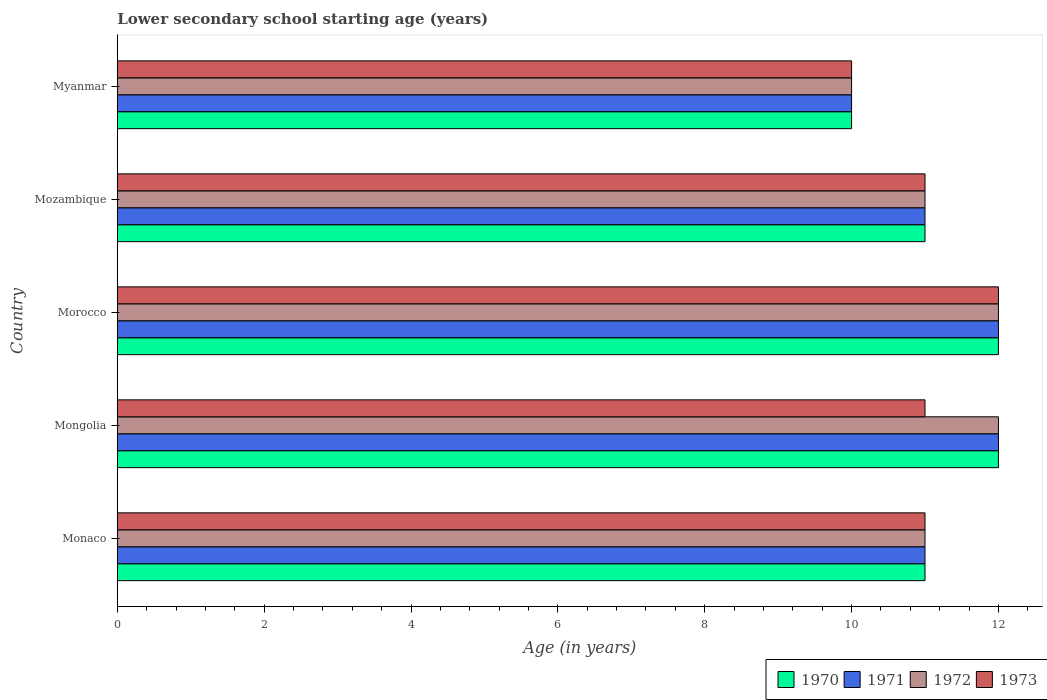Are the number of bars per tick equal to the number of legend labels?
Your answer should be very brief. Yes. Are the number of bars on each tick of the Y-axis equal?
Provide a succinct answer. Yes. How many bars are there on the 4th tick from the bottom?
Ensure brevity in your answer.  4. What is the label of the 4th group of bars from the top?
Provide a short and direct response. Mongolia. In how many cases, is the number of bars for a given country not equal to the number of legend labels?
Your response must be concise. 0. In which country was the lower secondary school starting age of children in 1972 maximum?
Give a very brief answer. Mongolia. In which country was the lower secondary school starting age of children in 1973 minimum?
Offer a terse response. Myanmar. What is the difference between the lower secondary school starting age of children in 1970 in Monaco and that in Mozambique?
Provide a succinct answer. 0. What is the difference between the lower secondary school starting age of children in 1970 in Mozambique and the lower secondary school starting age of children in 1973 in Mongolia?
Ensure brevity in your answer.  0. What is the average lower secondary school starting age of children in 1970 per country?
Make the answer very short. 11.2. In how many countries, is the lower secondary school starting age of children in 1972 greater than 9.6 years?
Provide a short and direct response. 5. What is the ratio of the lower secondary school starting age of children in 1971 in Monaco to that in Mozambique?
Offer a very short reply. 1. Is the lower secondary school starting age of children in 1973 in Mongolia less than that in Morocco?
Your answer should be very brief. Yes. Is the difference between the lower secondary school starting age of children in 1971 in Mongolia and Mozambique greater than the difference between the lower secondary school starting age of children in 1973 in Mongolia and Mozambique?
Provide a succinct answer. Yes. Is the sum of the lower secondary school starting age of children in 1971 in Monaco and Morocco greater than the maximum lower secondary school starting age of children in 1972 across all countries?
Offer a very short reply. Yes. Is it the case that in every country, the sum of the lower secondary school starting age of children in 1970 and lower secondary school starting age of children in 1971 is greater than the sum of lower secondary school starting age of children in 1973 and lower secondary school starting age of children in 1972?
Make the answer very short. No. What does the 4th bar from the top in Monaco represents?
Make the answer very short. 1970. What does the 4th bar from the bottom in Morocco represents?
Make the answer very short. 1973. How many bars are there?
Your answer should be very brief. 20. Are all the bars in the graph horizontal?
Provide a succinct answer. Yes. How many countries are there in the graph?
Your response must be concise. 5. Are the values on the major ticks of X-axis written in scientific E-notation?
Make the answer very short. No. Does the graph contain any zero values?
Offer a very short reply. No. How many legend labels are there?
Ensure brevity in your answer.  4. How are the legend labels stacked?
Offer a very short reply. Horizontal. What is the title of the graph?
Provide a succinct answer. Lower secondary school starting age (years). Does "1994" appear as one of the legend labels in the graph?
Ensure brevity in your answer.  No. What is the label or title of the X-axis?
Give a very brief answer. Age (in years). What is the Age (in years) in 1971 in Monaco?
Ensure brevity in your answer.  11. What is the Age (in years) in 1970 in Mongolia?
Your answer should be very brief. 12. What is the Age (in years) in 1973 in Mongolia?
Make the answer very short. 11. What is the Age (in years) in 1971 in Morocco?
Give a very brief answer. 12. What is the Age (in years) of 1972 in Morocco?
Your response must be concise. 12. What is the Age (in years) in 1973 in Morocco?
Your answer should be compact. 12. What is the Age (in years) in 1971 in Mozambique?
Your answer should be compact. 11. What is the Age (in years) of 1972 in Mozambique?
Your response must be concise. 11. What is the Age (in years) of 1971 in Myanmar?
Your response must be concise. 10. What is the Age (in years) of 1972 in Myanmar?
Your response must be concise. 10. What is the Age (in years) in 1973 in Myanmar?
Your answer should be compact. 10. Across all countries, what is the maximum Age (in years) of 1971?
Your answer should be very brief. 12. Across all countries, what is the maximum Age (in years) in 1972?
Offer a very short reply. 12. Across all countries, what is the maximum Age (in years) of 1973?
Your response must be concise. 12. Across all countries, what is the minimum Age (in years) of 1970?
Make the answer very short. 10. Across all countries, what is the minimum Age (in years) of 1972?
Ensure brevity in your answer.  10. What is the total Age (in years) of 1973 in the graph?
Provide a short and direct response. 55. What is the difference between the Age (in years) of 1970 in Monaco and that in Mongolia?
Provide a succinct answer. -1. What is the difference between the Age (in years) of 1971 in Monaco and that in Mongolia?
Offer a very short reply. -1. What is the difference between the Age (in years) in 1973 in Monaco and that in Mongolia?
Provide a succinct answer. 0. What is the difference between the Age (in years) in 1972 in Monaco and that in Morocco?
Ensure brevity in your answer.  -1. What is the difference between the Age (in years) in 1970 in Monaco and that in Mozambique?
Your answer should be very brief. 0. What is the difference between the Age (in years) in 1971 in Monaco and that in Myanmar?
Offer a terse response. 1. What is the difference between the Age (in years) in 1972 in Monaco and that in Myanmar?
Keep it short and to the point. 1. What is the difference between the Age (in years) of 1970 in Mongolia and that in Morocco?
Your answer should be compact. 0. What is the difference between the Age (in years) in 1971 in Mongolia and that in Morocco?
Make the answer very short. 0. What is the difference between the Age (in years) of 1973 in Mongolia and that in Morocco?
Ensure brevity in your answer.  -1. What is the difference between the Age (in years) in 1973 in Mongolia and that in Mozambique?
Provide a succinct answer. 0. What is the difference between the Age (in years) in 1971 in Mongolia and that in Myanmar?
Make the answer very short. 2. What is the difference between the Age (in years) in 1972 in Mongolia and that in Myanmar?
Your response must be concise. 2. What is the difference between the Age (in years) in 1973 in Mongolia and that in Myanmar?
Your answer should be compact. 1. What is the difference between the Age (in years) in 1972 in Morocco and that in Mozambique?
Keep it short and to the point. 1. What is the difference between the Age (in years) in 1973 in Morocco and that in Mozambique?
Make the answer very short. 1. What is the difference between the Age (in years) in 1971 in Morocco and that in Myanmar?
Keep it short and to the point. 2. What is the difference between the Age (in years) in 1973 in Morocco and that in Myanmar?
Provide a succinct answer. 2. What is the difference between the Age (in years) of 1973 in Mozambique and that in Myanmar?
Your response must be concise. 1. What is the difference between the Age (in years) in 1970 in Monaco and the Age (in years) in 1972 in Mongolia?
Provide a succinct answer. -1. What is the difference between the Age (in years) in 1971 in Monaco and the Age (in years) in 1973 in Mongolia?
Offer a terse response. 0. What is the difference between the Age (in years) in 1972 in Monaco and the Age (in years) in 1973 in Mongolia?
Your answer should be very brief. 0. What is the difference between the Age (in years) in 1970 in Monaco and the Age (in years) in 1971 in Morocco?
Ensure brevity in your answer.  -1. What is the difference between the Age (in years) in 1970 in Monaco and the Age (in years) in 1972 in Morocco?
Your answer should be compact. -1. What is the difference between the Age (in years) in 1971 in Monaco and the Age (in years) in 1973 in Morocco?
Give a very brief answer. -1. What is the difference between the Age (in years) of 1970 in Monaco and the Age (in years) of 1972 in Mozambique?
Provide a short and direct response. 0. What is the difference between the Age (in years) of 1971 in Monaco and the Age (in years) of 1972 in Mozambique?
Ensure brevity in your answer.  0. What is the difference between the Age (in years) of 1971 in Monaco and the Age (in years) of 1973 in Mozambique?
Provide a succinct answer. 0. What is the difference between the Age (in years) in 1972 in Monaco and the Age (in years) in 1973 in Mozambique?
Give a very brief answer. 0. What is the difference between the Age (in years) of 1971 in Monaco and the Age (in years) of 1973 in Myanmar?
Your answer should be compact. 1. What is the difference between the Age (in years) in 1970 in Mongolia and the Age (in years) in 1971 in Morocco?
Your response must be concise. 0. What is the difference between the Age (in years) in 1970 in Mongolia and the Age (in years) in 1972 in Morocco?
Your response must be concise. 0. What is the difference between the Age (in years) in 1970 in Mongolia and the Age (in years) in 1973 in Morocco?
Offer a very short reply. 0. What is the difference between the Age (in years) of 1972 in Mongolia and the Age (in years) of 1973 in Morocco?
Offer a terse response. 0. What is the difference between the Age (in years) of 1970 in Mongolia and the Age (in years) of 1971 in Mozambique?
Your response must be concise. 1. What is the difference between the Age (in years) of 1971 in Mongolia and the Age (in years) of 1972 in Mozambique?
Offer a very short reply. 1. What is the difference between the Age (in years) of 1972 in Mongolia and the Age (in years) of 1973 in Mozambique?
Keep it short and to the point. 1. What is the difference between the Age (in years) in 1970 in Mongolia and the Age (in years) in 1971 in Myanmar?
Ensure brevity in your answer.  2. What is the difference between the Age (in years) of 1971 in Mongolia and the Age (in years) of 1972 in Myanmar?
Ensure brevity in your answer.  2. What is the difference between the Age (in years) of 1971 in Mongolia and the Age (in years) of 1973 in Myanmar?
Provide a succinct answer. 2. What is the difference between the Age (in years) of 1972 in Mongolia and the Age (in years) of 1973 in Myanmar?
Your answer should be very brief. 2. What is the difference between the Age (in years) in 1970 in Morocco and the Age (in years) in 1971 in Mozambique?
Keep it short and to the point. 1. What is the difference between the Age (in years) in 1970 in Morocco and the Age (in years) in 1972 in Mozambique?
Offer a terse response. 1. What is the difference between the Age (in years) in 1971 in Morocco and the Age (in years) in 1972 in Mozambique?
Your answer should be very brief. 1. What is the difference between the Age (in years) in 1971 in Morocco and the Age (in years) in 1973 in Mozambique?
Give a very brief answer. 1. What is the difference between the Age (in years) in 1972 in Morocco and the Age (in years) in 1973 in Mozambique?
Offer a terse response. 1. What is the difference between the Age (in years) of 1970 in Morocco and the Age (in years) of 1971 in Myanmar?
Provide a succinct answer. 2. What is the difference between the Age (in years) of 1970 in Morocco and the Age (in years) of 1972 in Myanmar?
Provide a short and direct response. 2. What is the difference between the Age (in years) of 1970 in Morocco and the Age (in years) of 1973 in Myanmar?
Keep it short and to the point. 2. What is the difference between the Age (in years) of 1970 in Mozambique and the Age (in years) of 1973 in Myanmar?
Your answer should be compact. 1. What is the difference between the Age (in years) of 1971 in Mozambique and the Age (in years) of 1972 in Myanmar?
Provide a succinct answer. 1. What is the difference between the Age (in years) in 1971 in Mozambique and the Age (in years) in 1973 in Myanmar?
Offer a terse response. 1. What is the difference between the Age (in years) of 1972 in Mozambique and the Age (in years) of 1973 in Myanmar?
Make the answer very short. 1. What is the average Age (in years) of 1971 per country?
Keep it short and to the point. 11.2. What is the average Age (in years) in 1973 per country?
Offer a very short reply. 11. What is the difference between the Age (in years) in 1970 and Age (in years) in 1972 in Monaco?
Provide a succinct answer. 0. What is the difference between the Age (in years) of 1971 and Age (in years) of 1973 in Monaco?
Your answer should be very brief. 0. What is the difference between the Age (in years) in 1970 and Age (in years) in 1972 in Mongolia?
Offer a very short reply. 0. What is the difference between the Age (in years) of 1970 and Age (in years) of 1973 in Mongolia?
Offer a very short reply. 1. What is the difference between the Age (in years) of 1971 and Age (in years) of 1973 in Mongolia?
Keep it short and to the point. 1. What is the difference between the Age (in years) in 1970 and Age (in years) in 1971 in Morocco?
Your answer should be very brief. 0. What is the difference between the Age (in years) in 1971 and Age (in years) in 1973 in Morocco?
Your response must be concise. 0. What is the difference between the Age (in years) of 1970 and Age (in years) of 1971 in Mozambique?
Keep it short and to the point. 0. What is the difference between the Age (in years) of 1970 and Age (in years) of 1972 in Mozambique?
Your answer should be very brief. 0. What is the difference between the Age (in years) in 1971 and Age (in years) in 1972 in Mozambique?
Ensure brevity in your answer.  0. What is the difference between the Age (in years) in 1972 and Age (in years) in 1973 in Mozambique?
Provide a succinct answer. 0. What is the difference between the Age (in years) in 1970 and Age (in years) in 1972 in Myanmar?
Offer a terse response. 0. What is the difference between the Age (in years) of 1970 and Age (in years) of 1973 in Myanmar?
Your answer should be compact. 0. What is the difference between the Age (in years) of 1971 and Age (in years) of 1972 in Myanmar?
Your response must be concise. 0. What is the ratio of the Age (in years) of 1971 in Monaco to that in Mongolia?
Provide a short and direct response. 0.92. What is the ratio of the Age (in years) of 1970 in Monaco to that in Morocco?
Make the answer very short. 0.92. What is the ratio of the Age (in years) in 1971 in Monaco to that in Morocco?
Offer a terse response. 0.92. What is the ratio of the Age (in years) of 1970 in Monaco to that in Mozambique?
Keep it short and to the point. 1. What is the ratio of the Age (in years) in 1970 in Monaco to that in Myanmar?
Provide a short and direct response. 1.1. What is the ratio of the Age (in years) of 1971 in Monaco to that in Myanmar?
Your answer should be very brief. 1.1. What is the ratio of the Age (in years) of 1972 in Monaco to that in Myanmar?
Keep it short and to the point. 1.1. What is the ratio of the Age (in years) of 1970 in Mongolia to that in Morocco?
Provide a succinct answer. 1. What is the ratio of the Age (in years) in 1971 in Mongolia to that in Morocco?
Your answer should be very brief. 1. What is the ratio of the Age (in years) of 1972 in Mongolia to that in Morocco?
Give a very brief answer. 1. What is the ratio of the Age (in years) of 1973 in Mongolia to that in Morocco?
Your response must be concise. 0.92. What is the ratio of the Age (in years) in 1973 in Mongolia to that in Mozambique?
Keep it short and to the point. 1. What is the ratio of the Age (in years) of 1971 in Mongolia to that in Myanmar?
Provide a succinct answer. 1.2. What is the ratio of the Age (in years) in 1973 in Mongolia to that in Myanmar?
Your response must be concise. 1.1. What is the ratio of the Age (in years) in 1971 in Morocco to that in Mozambique?
Your answer should be compact. 1.09. What is the ratio of the Age (in years) of 1971 in Morocco to that in Myanmar?
Offer a very short reply. 1.2. What is the ratio of the Age (in years) of 1972 in Morocco to that in Myanmar?
Ensure brevity in your answer.  1.2. What is the ratio of the Age (in years) of 1970 in Mozambique to that in Myanmar?
Your response must be concise. 1.1. What is the ratio of the Age (in years) in 1971 in Mozambique to that in Myanmar?
Give a very brief answer. 1.1. What is the ratio of the Age (in years) of 1973 in Mozambique to that in Myanmar?
Provide a succinct answer. 1.1. What is the difference between the highest and the second highest Age (in years) in 1970?
Give a very brief answer. 0. 